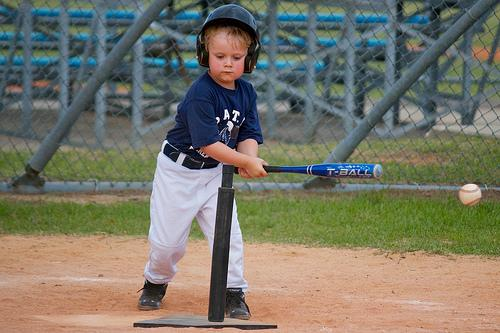Question: what is the boy holding?
Choices:
A. A bike.
B. A kite.
C. A bannna.
D. A bat.
Answer with the letter. Answer: D Question: who is holding a bat?
Choices:
A. A girl.
B. A boy.
C. Referee.
D. Boxer.
Answer with the letter. Answer: B Question: why the boy is holding a bat?
Choices:
A. To quit.
B. To sell it.
C. To trade it.
D. To play.
Answer with the letter. Answer: D Question: what is the color of the bat?
Choices:
A. Blue.
B. Black.
C. Green.
D. Red.
Answer with the letter. Answer: A Question: where is the kid?
Choices:
A. In The stands.
B. In the baseball field.
C. In the car.
D. Middle of field.
Answer with the letter. Answer: B Question: what is the color of the kid's helmet?
Choices:
A. Red.
B. Orange.
C. Black.
D. Gray.
Answer with the letter. Answer: C 